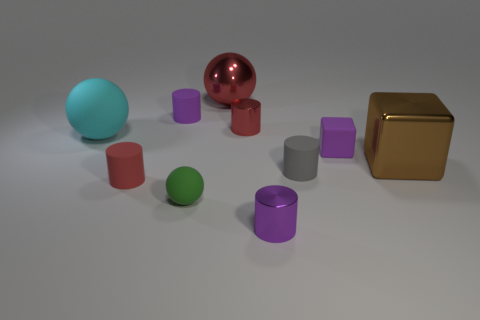What number of tiny gray metallic cylinders are there?
Offer a very short reply. 0. What material is the tiny red cylinder in front of the big cyan rubber sphere?
Provide a short and direct response. Rubber. Are there any brown things behind the big red metal thing?
Give a very brief answer. No. Do the red rubber object and the gray rubber thing have the same size?
Offer a terse response. Yes. How many small green balls have the same material as the cyan object?
Your answer should be very brief. 1. How big is the rubber thing in front of the red thing on the left side of the green matte object?
Ensure brevity in your answer.  Small. What color is the large thing that is both left of the tiny gray rubber cylinder and to the right of the cyan thing?
Give a very brief answer. Red. Is the shape of the small purple metallic object the same as the cyan object?
Your response must be concise. No. What size is the rubber object that is the same color as the rubber cube?
Provide a succinct answer. Small. There is a red thing behind the red cylinder behind the small block; what shape is it?
Offer a very short reply. Sphere. 